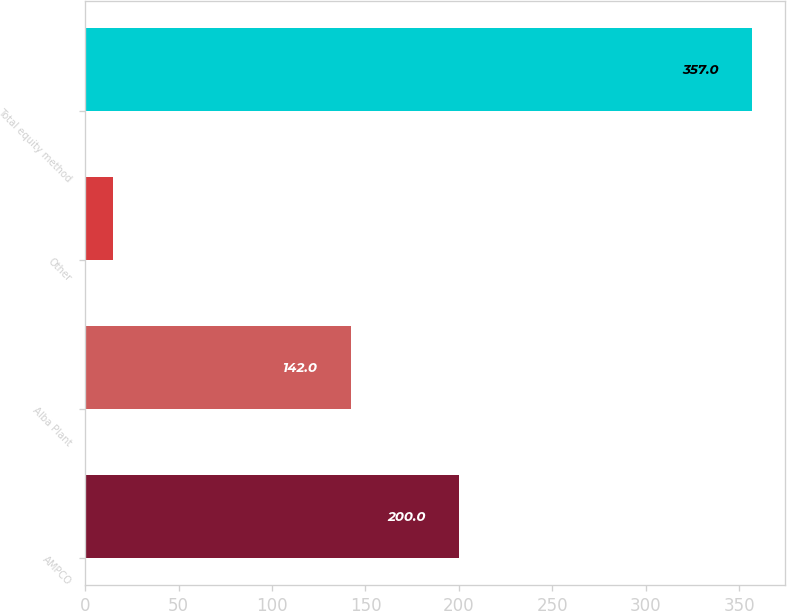Convert chart. <chart><loc_0><loc_0><loc_500><loc_500><bar_chart><fcel>AMPCO<fcel>Alba Plant<fcel>Other<fcel>Total equity method<nl><fcel>200<fcel>142<fcel>15<fcel>357<nl></chart> 